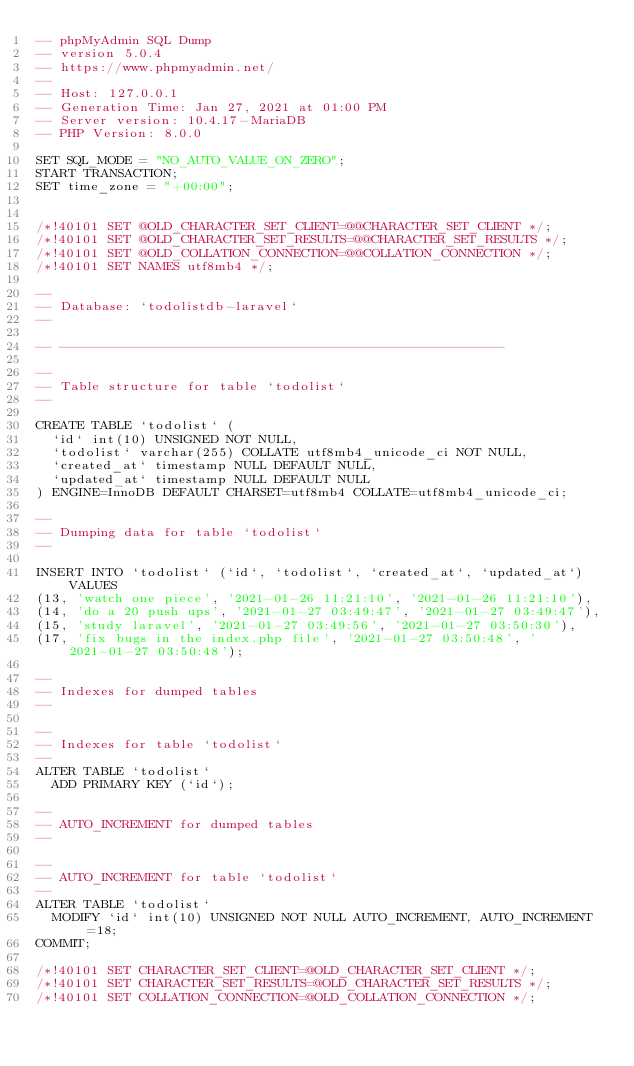<code> <loc_0><loc_0><loc_500><loc_500><_SQL_>-- phpMyAdmin SQL Dump
-- version 5.0.4
-- https://www.phpmyadmin.net/
--
-- Host: 127.0.0.1
-- Generation Time: Jan 27, 2021 at 01:00 PM
-- Server version: 10.4.17-MariaDB
-- PHP Version: 8.0.0

SET SQL_MODE = "NO_AUTO_VALUE_ON_ZERO";
START TRANSACTION;
SET time_zone = "+00:00";


/*!40101 SET @OLD_CHARACTER_SET_CLIENT=@@CHARACTER_SET_CLIENT */;
/*!40101 SET @OLD_CHARACTER_SET_RESULTS=@@CHARACTER_SET_RESULTS */;
/*!40101 SET @OLD_COLLATION_CONNECTION=@@COLLATION_CONNECTION */;
/*!40101 SET NAMES utf8mb4 */;

--
-- Database: `todolistdb-laravel`
--

-- --------------------------------------------------------

--
-- Table structure for table `todolist`
--

CREATE TABLE `todolist` (
  `id` int(10) UNSIGNED NOT NULL,
  `todolist` varchar(255) COLLATE utf8mb4_unicode_ci NOT NULL,
  `created_at` timestamp NULL DEFAULT NULL,
  `updated_at` timestamp NULL DEFAULT NULL
) ENGINE=InnoDB DEFAULT CHARSET=utf8mb4 COLLATE=utf8mb4_unicode_ci;

--
-- Dumping data for table `todolist`
--

INSERT INTO `todolist` (`id`, `todolist`, `created_at`, `updated_at`) VALUES
(13, 'watch one piece', '2021-01-26 11:21:10', '2021-01-26 11:21:10'),
(14, 'do a 20 push ups', '2021-01-27 03:49:47', '2021-01-27 03:49:47'),
(15, 'study laravel', '2021-01-27 03:49:56', '2021-01-27 03:50:30'),
(17, 'fix bugs in the index.php file', '2021-01-27 03:50:48', '2021-01-27 03:50:48');

--
-- Indexes for dumped tables
--

--
-- Indexes for table `todolist`
--
ALTER TABLE `todolist`
  ADD PRIMARY KEY (`id`);

--
-- AUTO_INCREMENT for dumped tables
--

--
-- AUTO_INCREMENT for table `todolist`
--
ALTER TABLE `todolist`
  MODIFY `id` int(10) UNSIGNED NOT NULL AUTO_INCREMENT, AUTO_INCREMENT=18;
COMMIT;

/*!40101 SET CHARACTER_SET_CLIENT=@OLD_CHARACTER_SET_CLIENT */;
/*!40101 SET CHARACTER_SET_RESULTS=@OLD_CHARACTER_SET_RESULTS */;
/*!40101 SET COLLATION_CONNECTION=@OLD_COLLATION_CONNECTION */;
</code> 